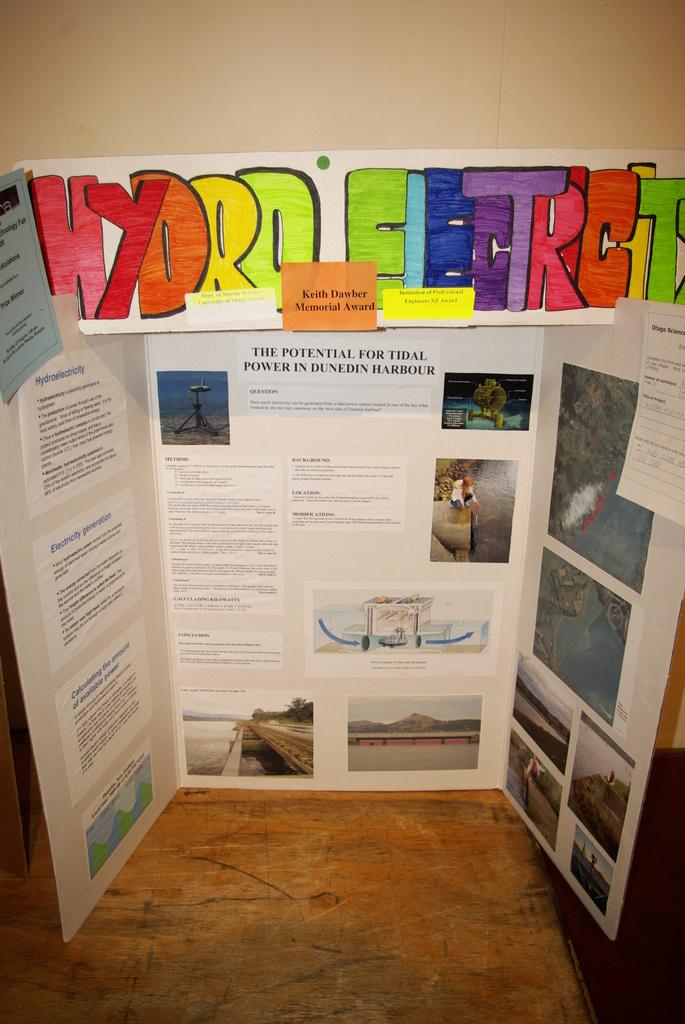<image>
Create a compact narrative representing the image presented. A poster presentation about the potential for tidal power in Dunedin Harbor won the Keith Dawber Memorial Award. 